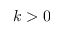Convert formula to latex. <formula><loc_0><loc_0><loc_500><loc_500>k > 0</formula> 